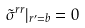Convert formula to latex. <formula><loc_0><loc_0><loc_500><loc_500>\tilde { \sigma } ^ { r r } | _ { r ^ { \prime } = b } = 0</formula> 